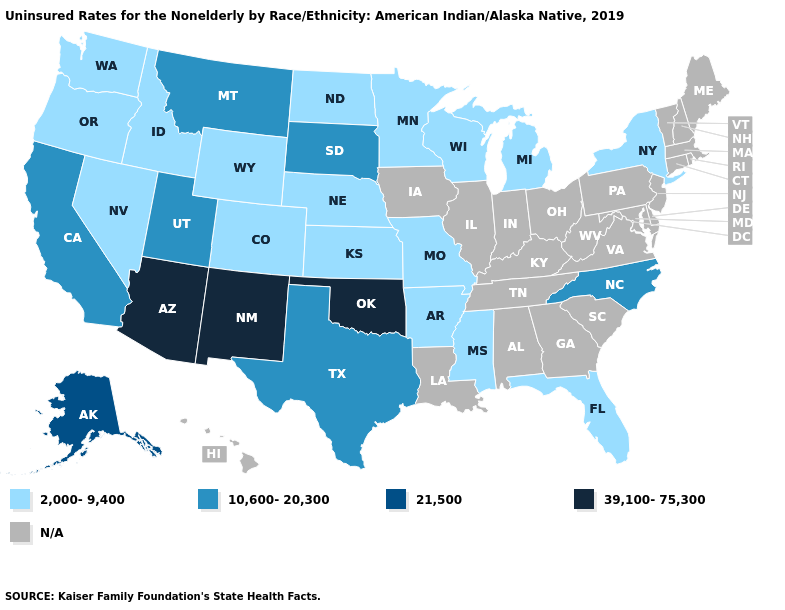What is the value of California?
Short answer required. 10,600-20,300. What is the value of North Dakota?
Quick response, please. 2,000-9,400. Does Wisconsin have the lowest value in the USA?
Short answer required. Yes. What is the value of Florida?
Concise answer only. 2,000-9,400. What is the highest value in states that border Kansas?
Concise answer only. 39,100-75,300. What is the highest value in the West ?
Be succinct. 39,100-75,300. Name the states that have a value in the range 2,000-9,400?
Concise answer only. Arkansas, Colorado, Florida, Idaho, Kansas, Michigan, Minnesota, Mississippi, Missouri, Nebraska, Nevada, New York, North Dakota, Oregon, Washington, Wisconsin, Wyoming. Name the states that have a value in the range 39,100-75,300?
Short answer required. Arizona, New Mexico, Oklahoma. How many symbols are there in the legend?
Short answer required. 5. Name the states that have a value in the range 39,100-75,300?
Keep it brief. Arizona, New Mexico, Oklahoma. What is the value of Minnesota?
Keep it brief. 2,000-9,400. What is the value of Wisconsin?
Answer briefly. 2,000-9,400. 